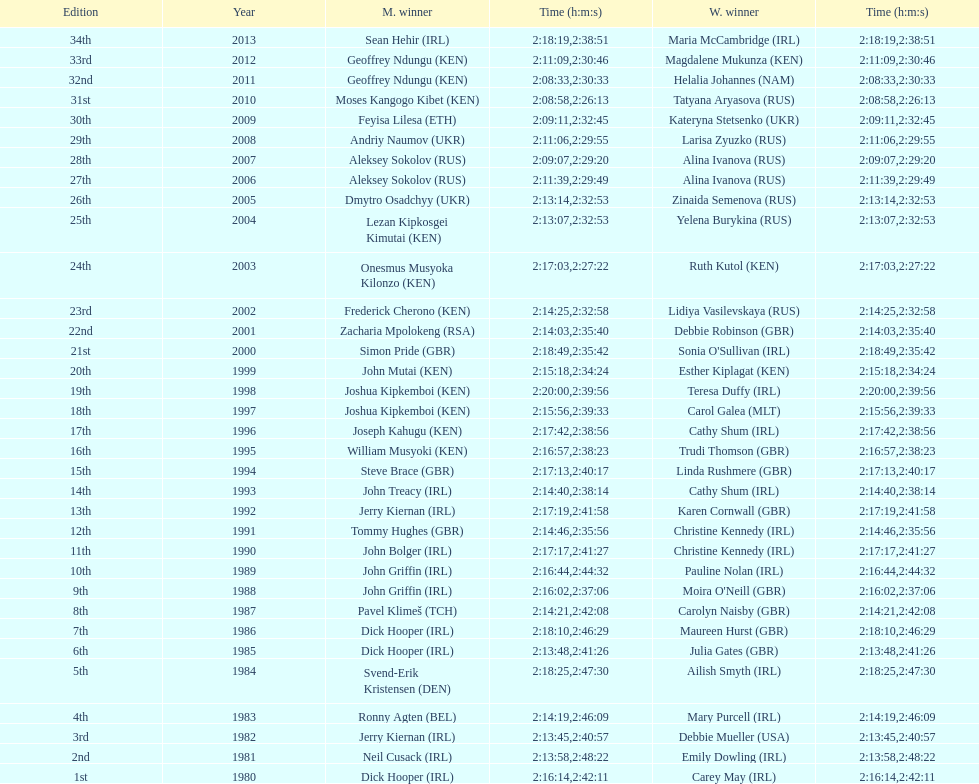I'm looking to parse the entire table for insights. Could you assist me with that? {'header': ['Edition', 'Year', 'M. winner', 'Time (h:m:s)', 'W. winner', 'Time (h:m:s)'], 'rows': [['34th', '2013', 'Sean Hehir\xa0(IRL)', '2:18:19', 'Maria McCambridge\xa0(IRL)', '2:38:51'], ['33rd', '2012', 'Geoffrey Ndungu\xa0(KEN)', '2:11:09', 'Magdalene Mukunza\xa0(KEN)', '2:30:46'], ['32nd', '2011', 'Geoffrey Ndungu\xa0(KEN)', '2:08:33', 'Helalia Johannes\xa0(NAM)', '2:30:33'], ['31st', '2010', 'Moses Kangogo Kibet\xa0(KEN)', '2:08:58', 'Tatyana Aryasova\xa0(RUS)', '2:26:13'], ['30th', '2009', 'Feyisa Lilesa\xa0(ETH)', '2:09:11', 'Kateryna Stetsenko\xa0(UKR)', '2:32:45'], ['29th', '2008', 'Andriy Naumov\xa0(UKR)', '2:11:06', 'Larisa Zyuzko\xa0(RUS)', '2:29:55'], ['28th', '2007', 'Aleksey Sokolov\xa0(RUS)', '2:09:07', 'Alina Ivanova\xa0(RUS)', '2:29:20'], ['27th', '2006', 'Aleksey Sokolov\xa0(RUS)', '2:11:39', 'Alina Ivanova\xa0(RUS)', '2:29:49'], ['26th', '2005', 'Dmytro Osadchyy\xa0(UKR)', '2:13:14', 'Zinaida Semenova\xa0(RUS)', '2:32:53'], ['25th', '2004', 'Lezan Kipkosgei Kimutai\xa0(KEN)', '2:13:07', 'Yelena Burykina\xa0(RUS)', '2:32:53'], ['24th', '2003', 'Onesmus Musyoka Kilonzo\xa0(KEN)', '2:17:03', 'Ruth Kutol\xa0(KEN)', '2:27:22'], ['23rd', '2002', 'Frederick Cherono\xa0(KEN)', '2:14:25', 'Lidiya Vasilevskaya\xa0(RUS)', '2:32:58'], ['22nd', '2001', 'Zacharia Mpolokeng\xa0(RSA)', '2:14:03', 'Debbie Robinson\xa0(GBR)', '2:35:40'], ['21st', '2000', 'Simon Pride\xa0(GBR)', '2:18:49', "Sonia O'Sullivan\xa0(IRL)", '2:35:42'], ['20th', '1999', 'John Mutai\xa0(KEN)', '2:15:18', 'Esther Kiplagat\xa0(KEN)', '2:34:24'], ['19th', '1998', 'Joshua Kipkemboi\xa0(KEN)', '2:20:00', 'Teresa Duffy\xa0(IRL)', '2:39:56'], ['18th', '1997', 'Joshua Kipkemboi\xa0(KEN)', '2:15:56', 'Carol Galea\xa0(MLT)', '2:39:33'], ['17th', '1996', 'Joseph Kahugu\xa0(KEN)', '2:17:42', 'Cathy Shum\xa0(IRL)', '2:38:56'], ['16th', '1995', 'William Musyoki\xa0(KEN)', '2:16:57', 'Trudi Thomson\xa0(GBR)', '2:38:23'], ['15th', '1994', 'Steve Brace\xa0(GBR)', '2:17:13', 'Linda Rushmere\xa0(GBR)', '2:40:17'], ['14th', '1993', 'John Treacy\xa0(IRL)', '2:14:40', 'Cathy Shum\xa0(IRL)', '2:38:14'], ['13th', '1992', 'Jerry Kiernan\xa0(IRL)', '2:17:19', 'Karen Cornwall\xa0(GBR)', '2:41:58'], ['12th', '1991', 'Tommy Hughes\xa0(GBR)', '2:14:46', 'Christine Kennedy\xa0(IRL)', '2:35:56'], ['11th', '1990', 'John Bolger\xa0(IRL)', '2:17:17', 'Christine Kennedy\xa0(IRL)', '2:41:27'], ['10th', '1989', 'John Griffin\xa0(IRL)', '2:16:44', 'Pauline Nolan\xa0(IRL)', '2:44:32'], ['9th', '1988', 'John Griffin\xa0(IRL)', '2:16:02', "Moira O'Neill\xa0(GBR)", '2:37:06'], ['8th', '1987', 'Pavel Klimeš\xa0(TCH)', '2:14:21', 'Carolyn Naisby\xa0(GBR)', '2:42:08'], ['7th', '1986', 'Dick Hooper\xa0(IRL)', '2:18:10', 'Maureen Hurst\xa0(GBR)', '2:46:29'], ['6th', '1985', 'Dick Hooper\xa0(IRL)', '2:13:48', 'Julia Gates\xa0(GBR)', '2:41:26'], ['5th', '1984', 'Svend-Erik Kristensen\xa0(DEN)', '2:18:25', 'Ailish Smyth\xa0(IRL)', '2:47:30'], ['4th', '1983', 'Ronny Agten\xa0(BEL)', '2:14:19', 'Mary Purcell\xa0(IRL)', '2:46:09'], ['3rd', '1982', 'Jerry Kiernan\xa0(IRL)', '2:13:45', 'Debbie Mueller\xa0(USA)', '2:40:57'], ['2nd', '1981', 'Neil Cusack\xa0(IRL)', '2:13:58', 'Emily Dowling\xa0(IRL)', '2:48:22'], ['1st', '1980', 'Dick Hooper\xa0(IRL)', '2:16:14', 'Carey May\xa0(IRL)', '2:42:11']]} Who achieved victory at least thrice in the men's? Dick Hooper (IRL). 